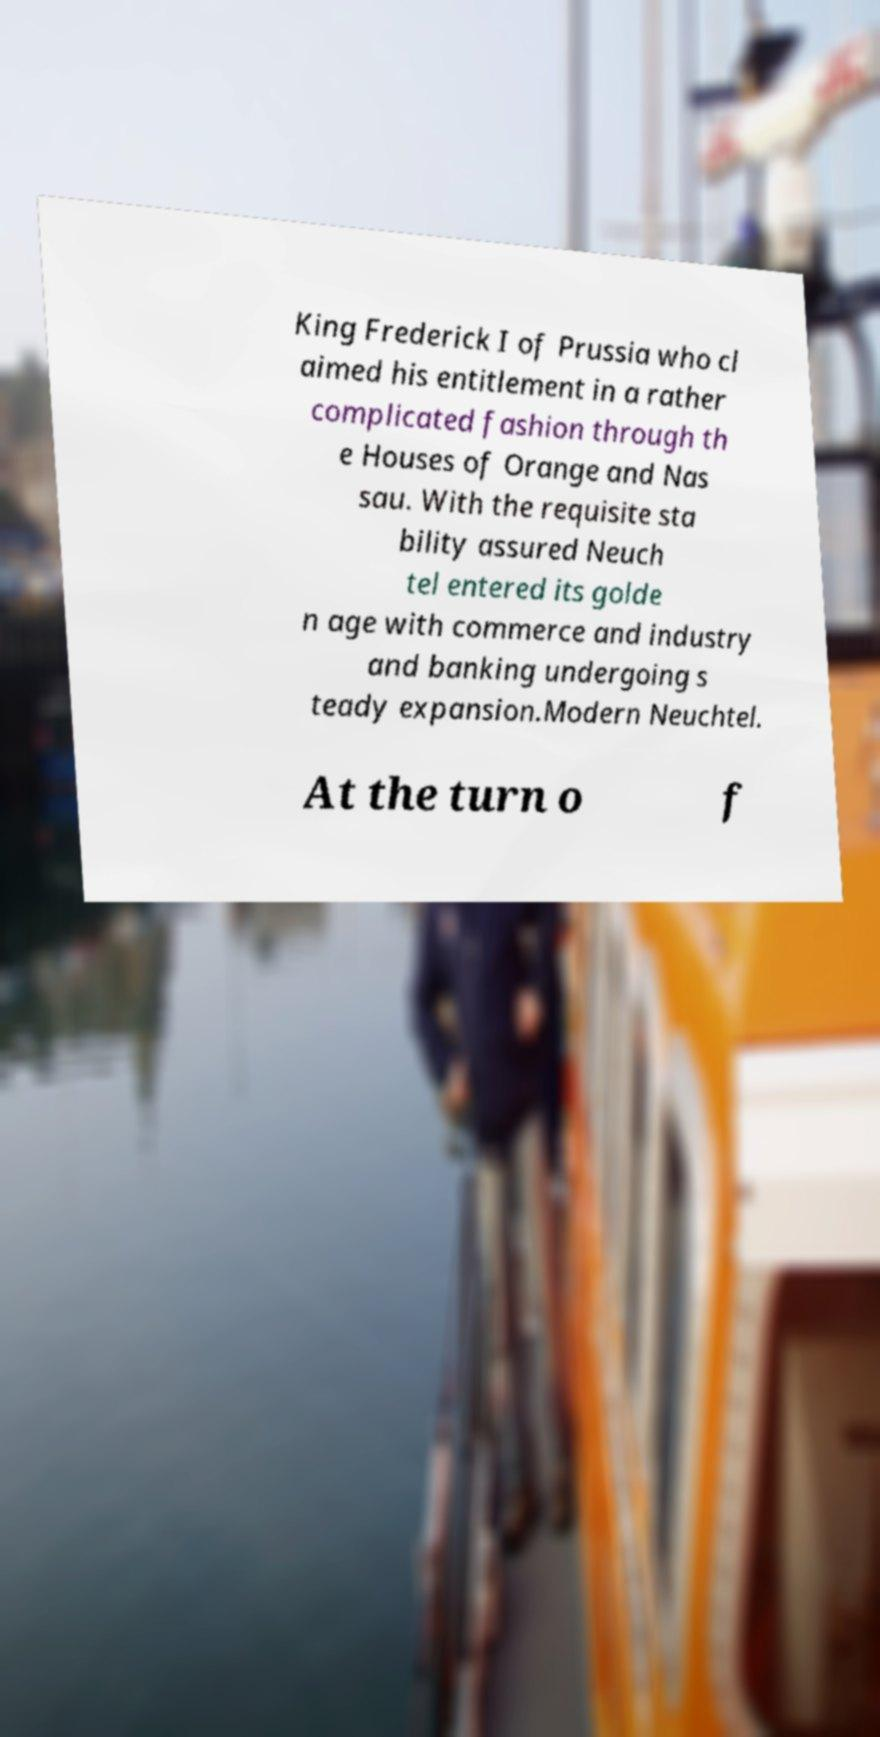Can you accurately transcribe the text from the provided image for me? King Frederick I of Prussia who cl aimed his entitlement in a rather complicated fashion through th e Houses of Orange and Nas sau. With the requisite sta bility assured Neuch tel entered its golde n age with commerce and industry and banking undergoing s teady expansion.Modern Neuchtel. At the turn o f 